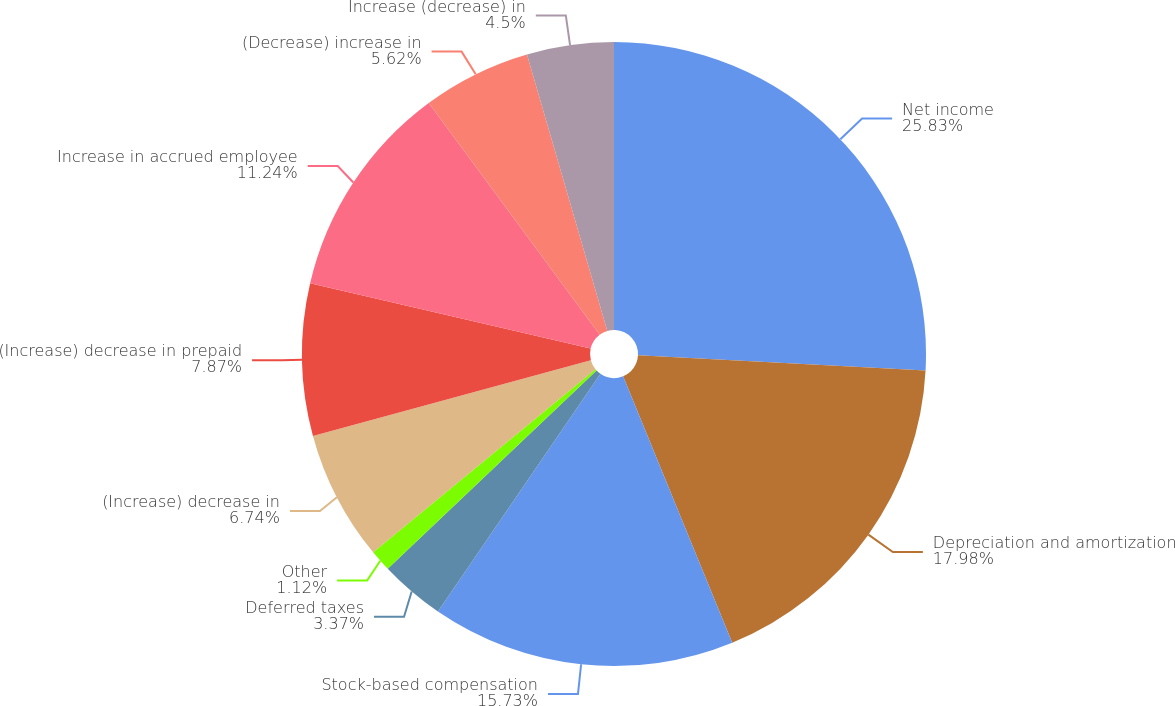<chart> <loc_0><loc_0><loc_500><loc_500><pie_chart><fcel>Net income<fcel>Depreciation and amortization<fcel>Stock-based compensation<fcel>Deferred taxes<fcel>Other<fcel>(Increase) decrease in<fcel>(Increase) decrease in prepaid<fcel>Increase in accrued employee<fcel>(Decrease) increase in<fcel>Increase (decrease) in<nl><fcel>25.84%<fcel>17.98%<fcel>15.73%<fcel>3.37%<fcel>1.12%<fcel>6.74%<fcel>7.87%<fcel>11.24%<fcel>5.62%<fcel>4.5%<nl></chart> 